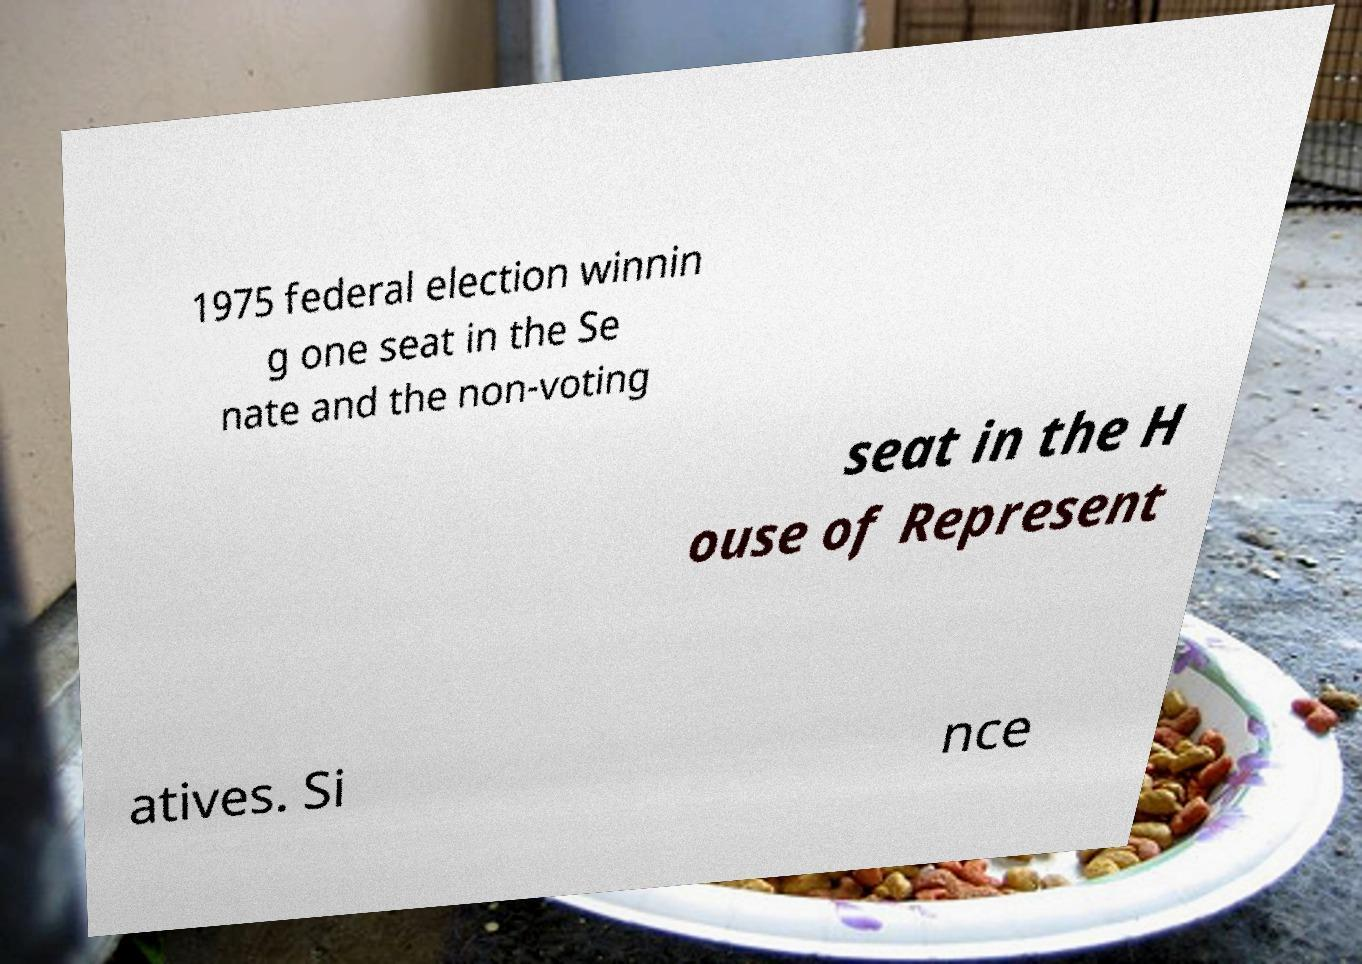I need the written content from this picture converted into text. Can you do that? 1975 federal election winnin g one seat in the Se nate and the non-voting seat in the H ouse of Represent atives. Si nce 